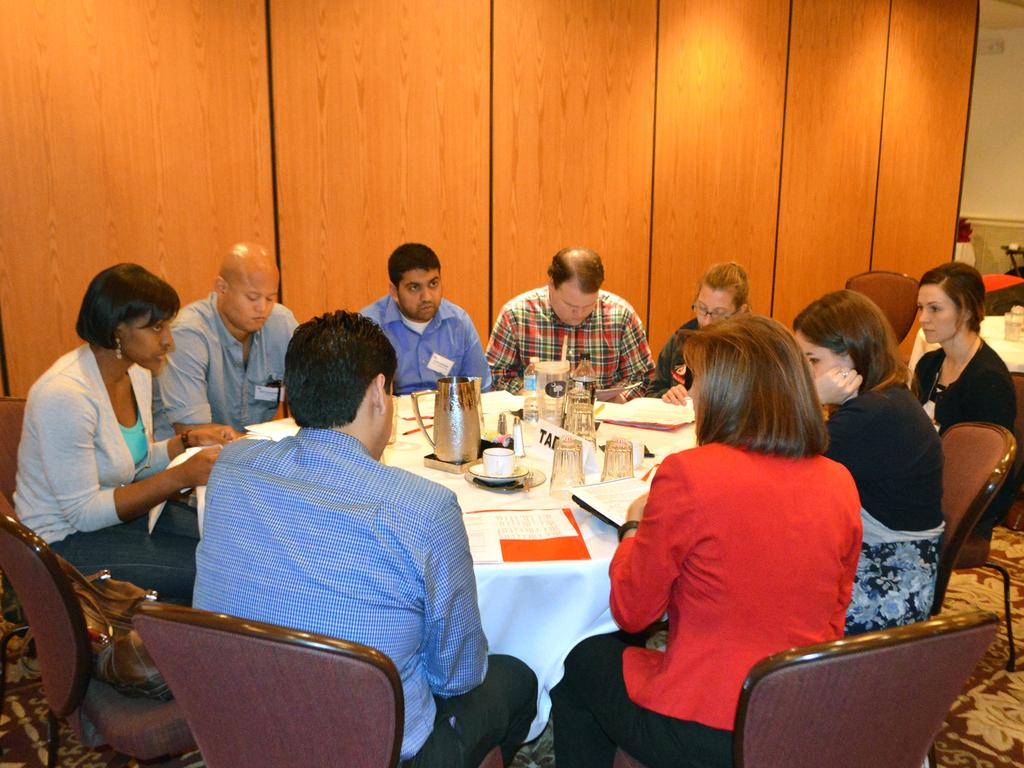How many people are present in the image? There are many people in the image. What are the people doing in the image? The people are sitting around a table. What are the people sitting on? The people are sitting on chairs. What can be seen on the table in the image? There are many items on the table. What is the tendency of the chin in the image? There is no chin present in the image, as it features a group of people sitting around a table. 